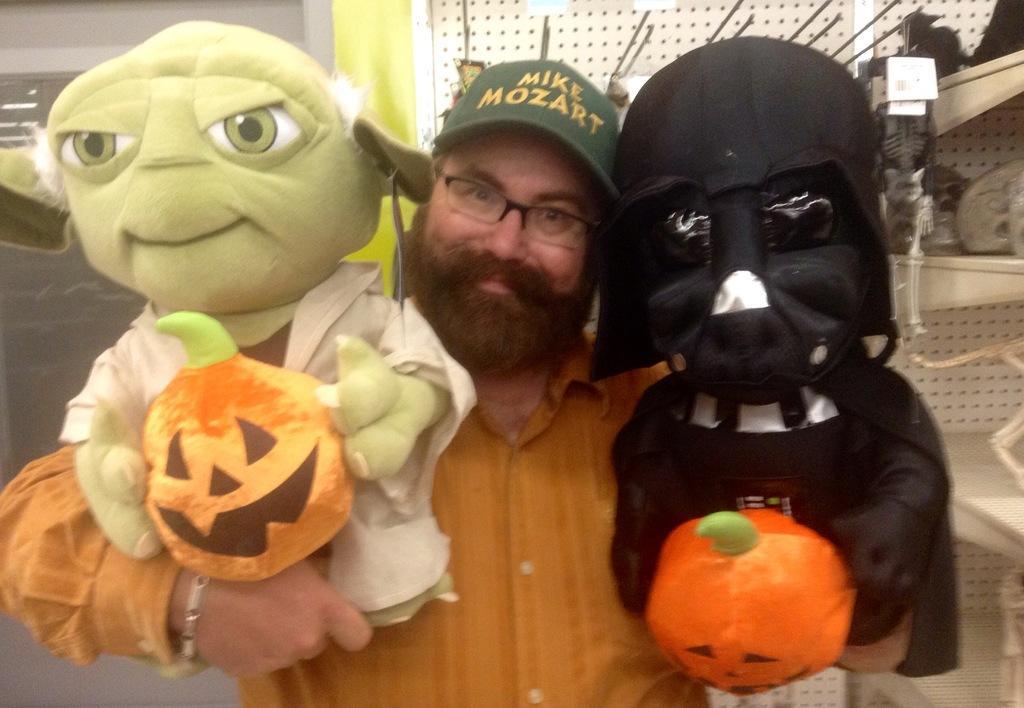How would you summarize this image in a sentence or two? In this picture there is a person standing and holding the toys. On the right side of the image there are toys in the cupboard. At the back there is wall. At the top there are lights. 